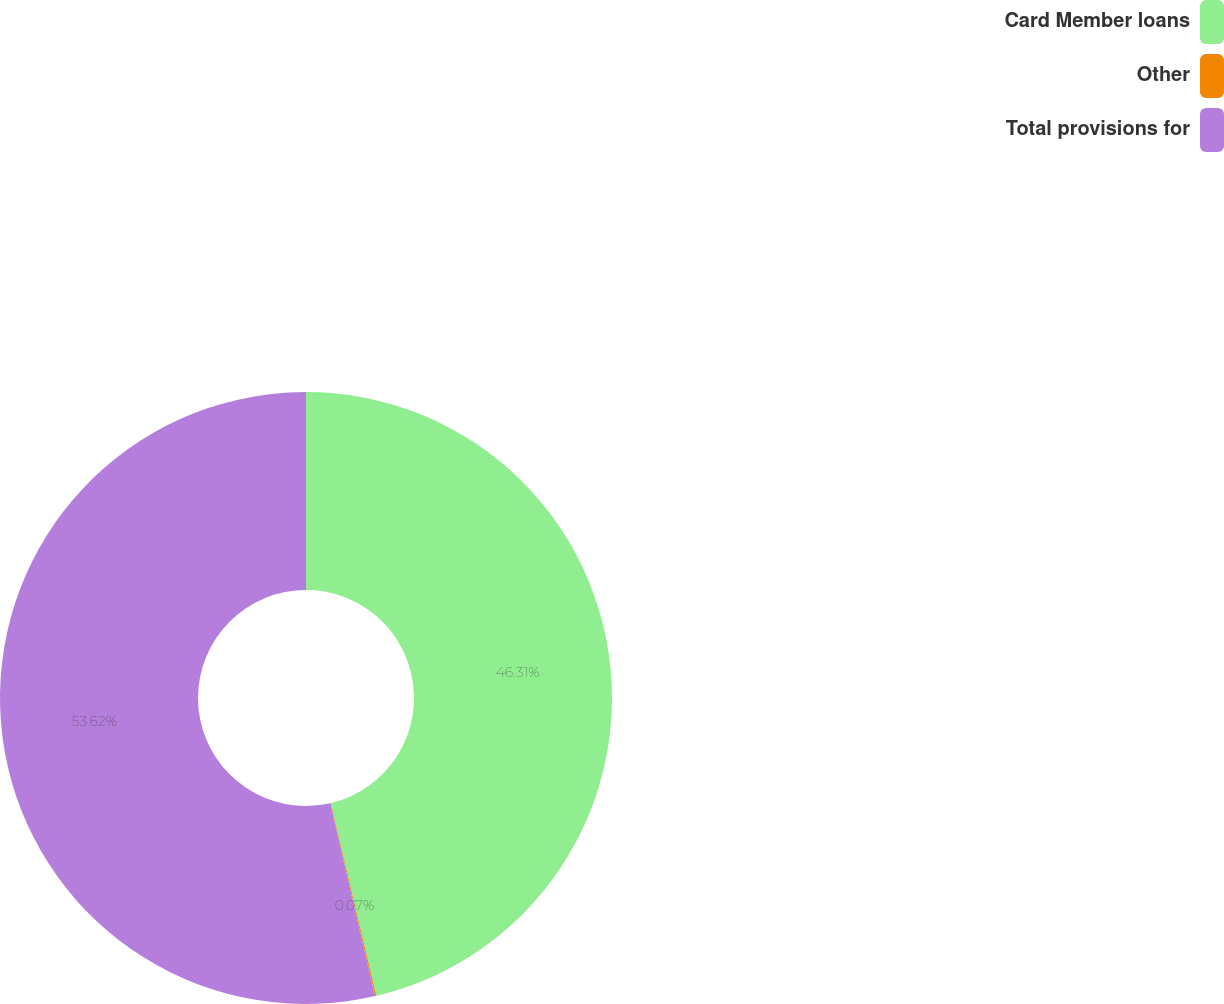Convert chart. <chart><loc_0><loc_0><loc_500><loc_500><pie_chart><fcel>Card Member loans<fcel>Other<fcel>Total provisions for<nl><fcel>46.31%<fcel>0.07%<fcel>53.62%<nl></chart> 